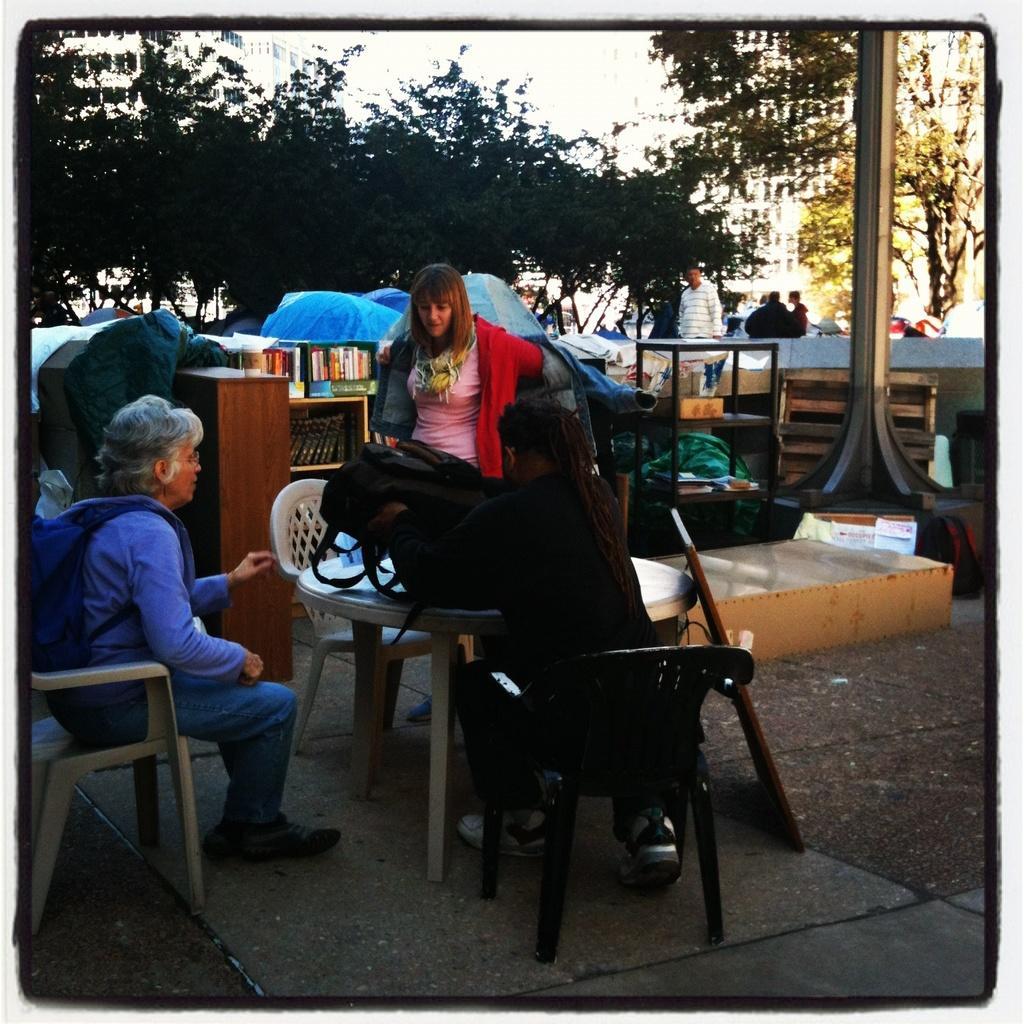Please provide a concise description of this image. In this image there are 2 persons sitting in a chair , there is another woman standing near a table, there is bag , tent , books in a rack , wooden frame, bench , tree, group of people standing, sky. 